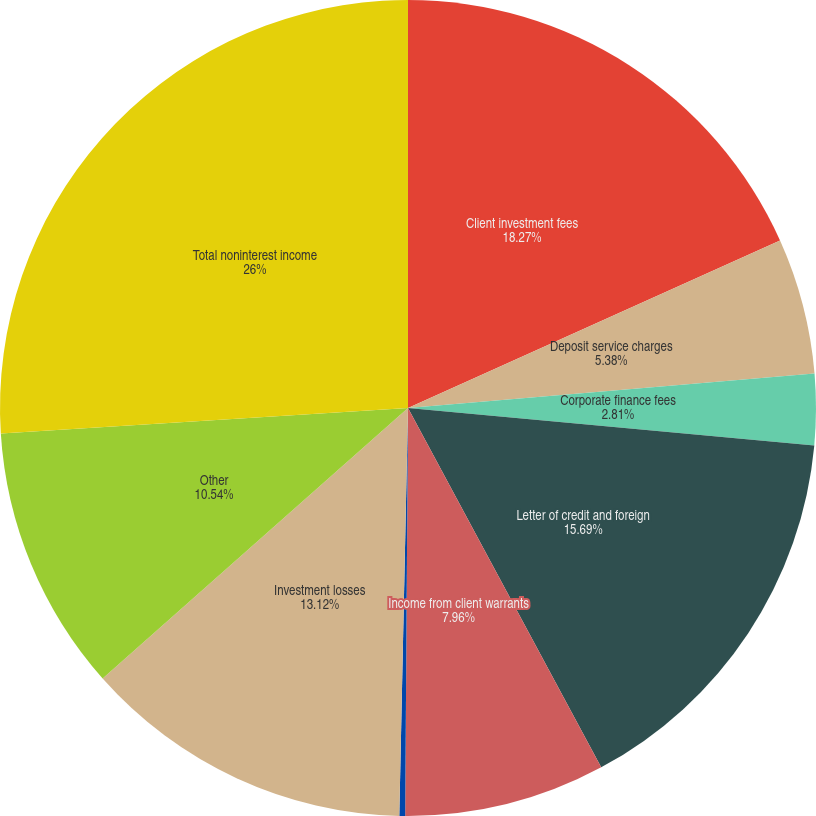Convert chart. <chart><loc_0><loc_0><loc_500><loc_500><pie_chart><fcel>Client investment fees<fcel>Deposit service charges<fcel>Corporate finance fees<fcel>Letter of credit and foreign<fcel>Income from client warrants<fcel>Credit card fees<fcel>Investment losses<fcel>Other<fcel>Total noninterest income<nl><fcel>18.27%<fcel>5.38%<fcel>2.81%<fcel>15.69%<fcel>7.96%<fcel>0.23%<fcel>13.12%<fcel>10.54%<fcel>26.0%<nl></chart> 